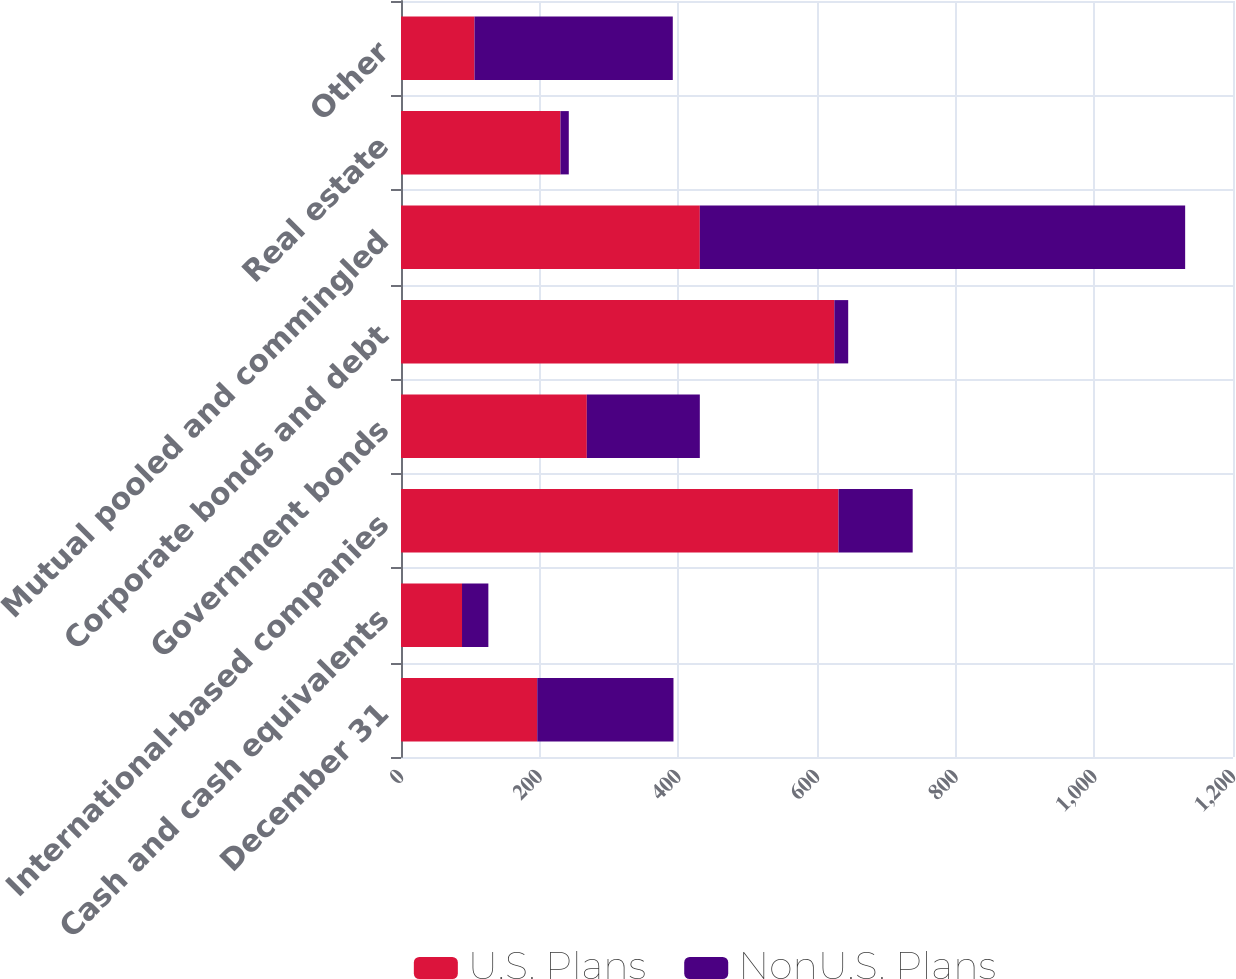Convert chart. <chart><loc_0><loc_0><loc_500><loc_500><stacked_bar_chart><ecel><fcel>December 31<fcel>Cash and cash equivalents<fcel>International-based companies<fcel>Government bonds<fcel>Corporate bonds and debt<fcel>Mutual pooled and commingled<fcel>Real estate<fcel>Other<nl><fcel>U.S. Plans<fcel>196.5<fcel>88<fcel>631<fcel>268<fcel>625<fcel>431<fcel>230<fcel>106<nl><fcel>NonU.S. Plans<fcel>196.5<fcel>38<fcel>107<fcel>163<fcel>20<fcel>700<fcel>12<fcel>286<nl></chart> 